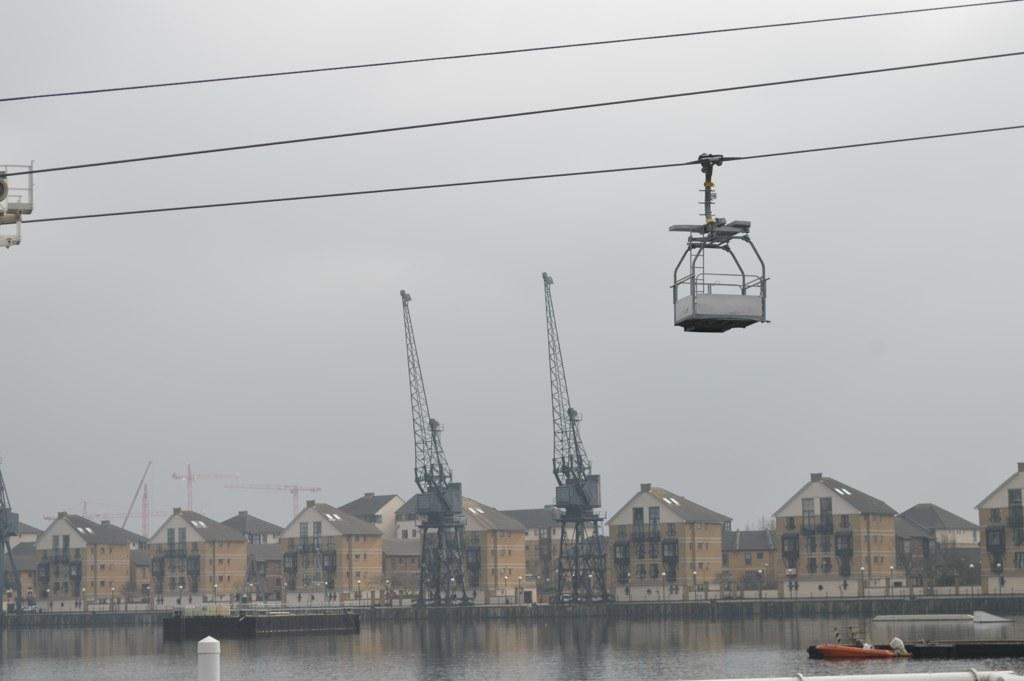Can you describe this image briefly? At the bottom of the image there is water and we can see a boat on the water. In the background there are sheds and towers. At the top there are ropes and a ropeway. In the background there is sky. 